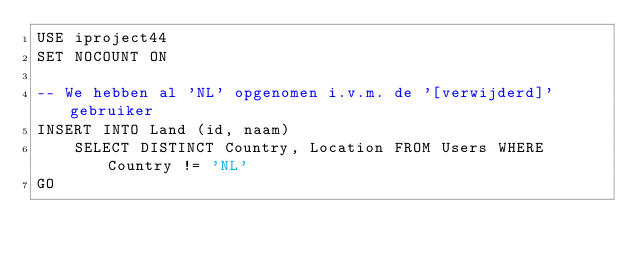Convert code to text. <code><loc_0><loc_0><loc_500><loc_500><_SQL_>USE iproject44
SET NOCOUNT ON

-- We hebben al 'NL' opgenomen i.v.m. de '[verwijderd]' gebruiker
INSERT INTO Land (id, naam)
    SELECT DISTINCT Country, Location FROM Users WHERE Country != 'NL'
GO
</code> 